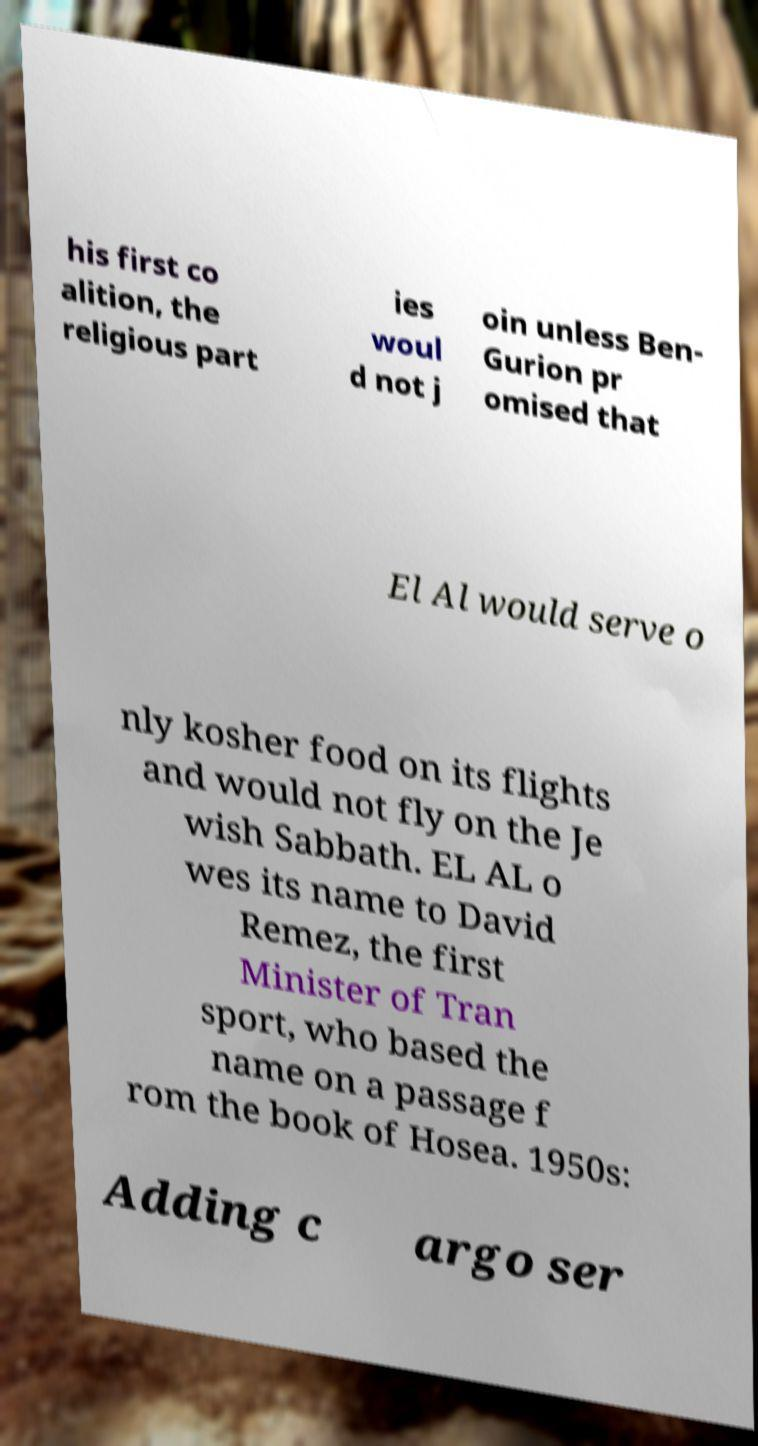Please read and relay the text visible in this image. What does it say? his first co alition, the religious part ies woul d not j oin unless Ben- Gurion pr omised that El Al would serve o nly kosher food on its flights and would not fly on the Je wish Sabbath. EL AL o wes its name to David Remez, the first Minister of Tran sport, who based the name on a passage f rom the book of Hosea. 1950s: Adding c argo ser 